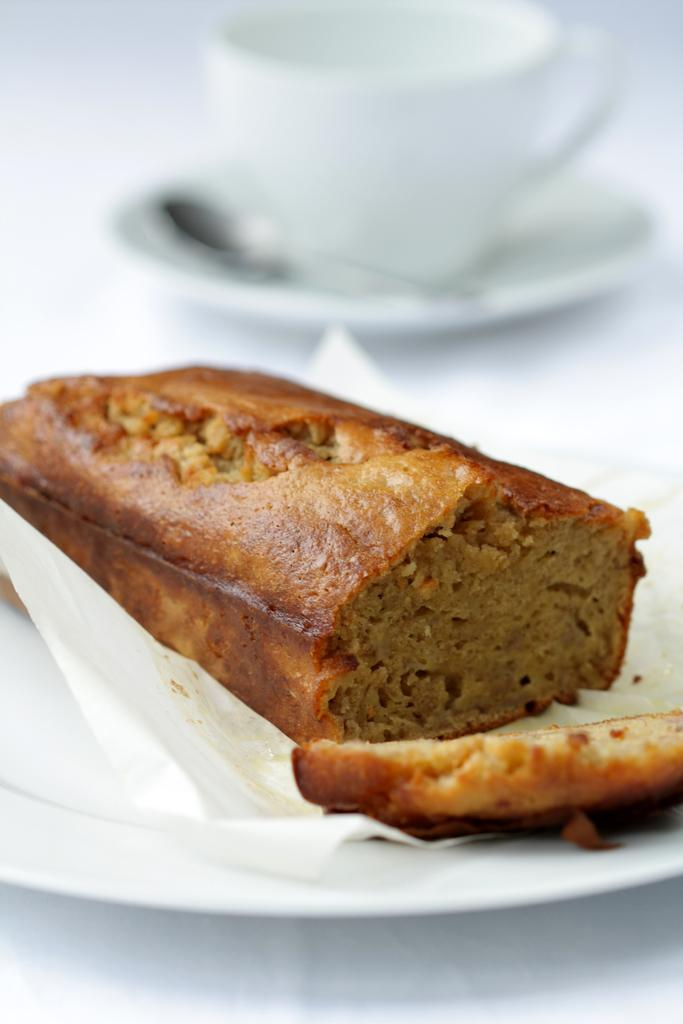What is on the plate that is visible in the image? The plate contains food items. What is the color of the surface on which the plate is placed? The plate is placed on a white surface. What is the cup's position in relation to the plate? The cup is in a saucer. What type of hate can be seen in the image? There is no hate present in the image. What offer is being made in the image? There is no offer being made in the image. 